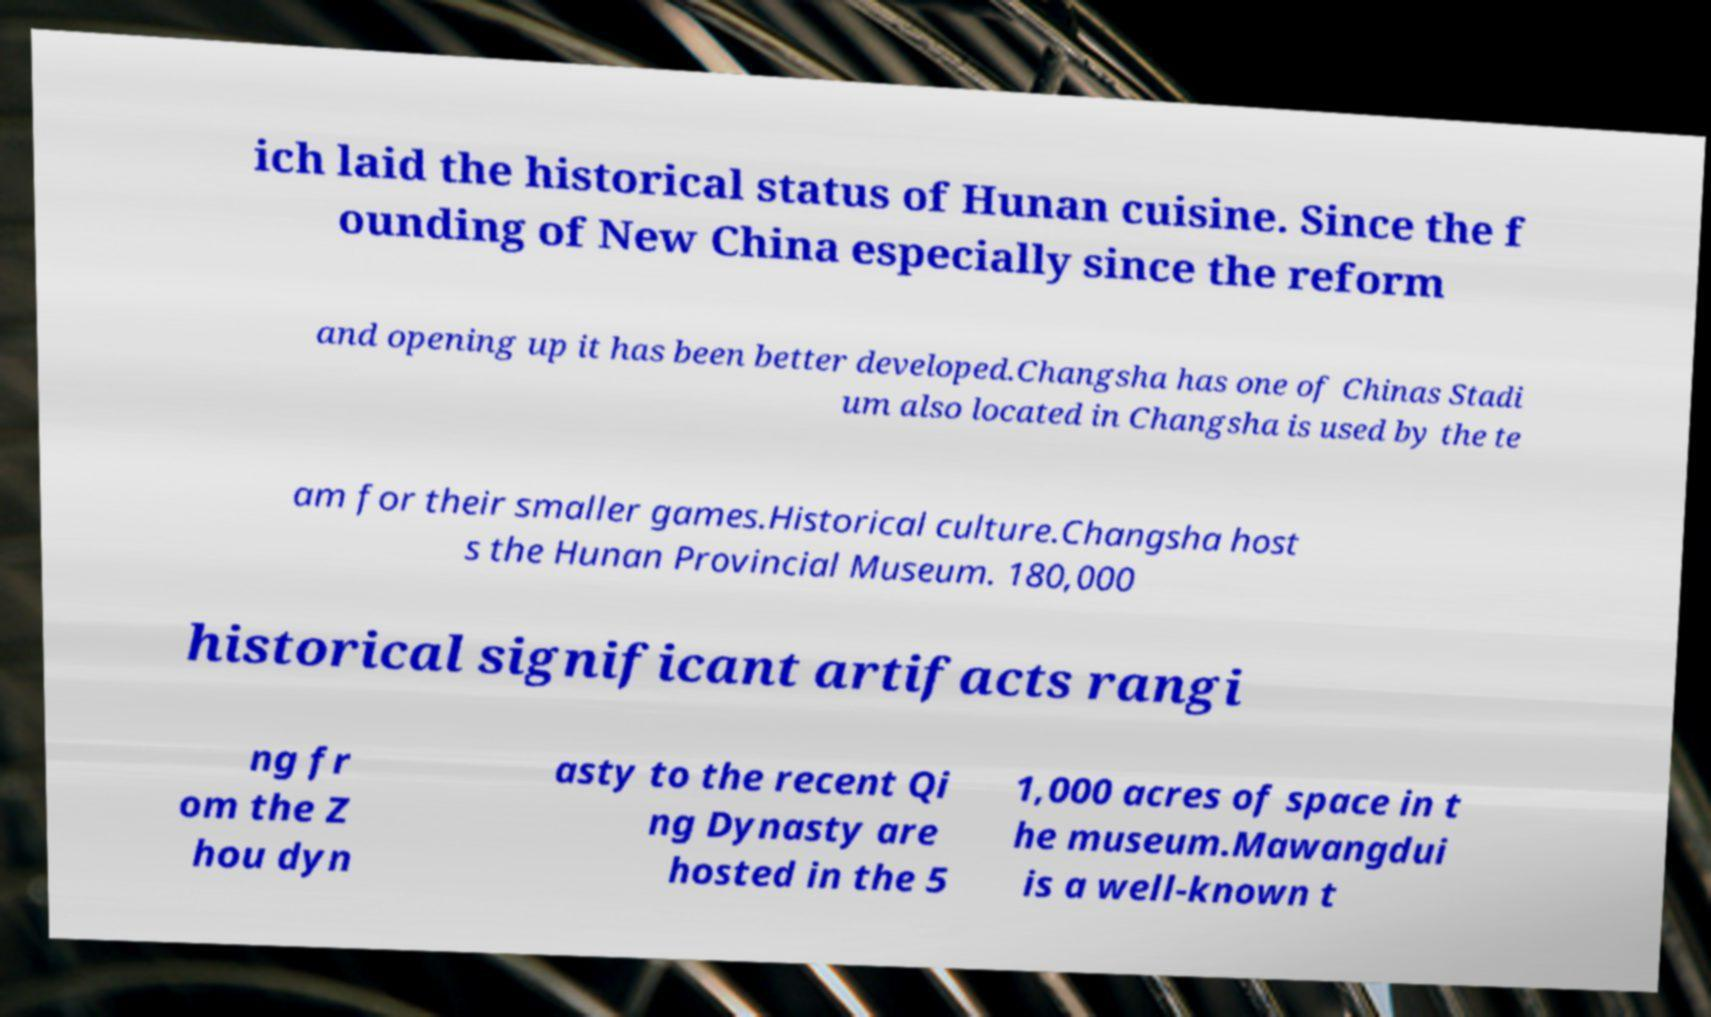I need the written content from this picture converted into text. Can you do that? ich laid the historical status of Hunan cuisine. Since the f ounding of New China especially since the reform and opening up it has been better developed.Changsha has one of Chinas Stadi um also located in Changsha is used by the te am for their smaller games.Historical culture.Changsha host s the Hunan Provincial Museum. 180,000 historical significant artifacts rangi ng fr om the Z hou dyn asty to the recent Qi ng Dynasty are hosted in the 5 1,000 acres of space in t he museum.Mawangdui is a well-known t 